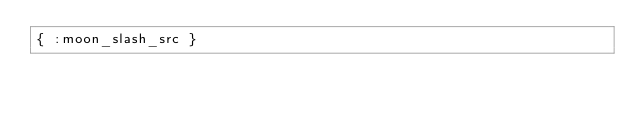<code> <loc_0><loc_0><loc_500><loc_500><_MoonScript_>{ :moon_slash_src }
</code> 